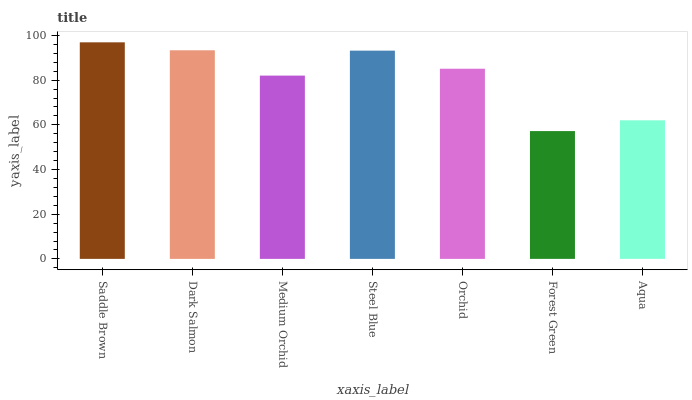Is Forest Green the minimum?
Answer yes or no. Yes. Is Saddle Brown the maximum?
Answer yes or no. Yes. Is Dark Salmon the minimum?
Answer yes or no. No. Is Dark Salmon the maximum?
Answer yes or no. No. Is Saddle Brown greater than Dark Salmon?
Answer yes or no. Yes. Is Dark Salmon less than Saddle Brown?
Answer yes or no. Yes. Is Dark Salmon greater than Saddle Brown?
Answer yes or no. No. Is Saddle Brown less than Dark Salmon?
Answer yes or no. No. Is Orchid the high median?
Answer yes or no. Yes. Is Orchid the low median?
Answer yes or no. Yes. Is Medium Orchid the high median?
Answer yes or no. No. Is Forest Green the low median?
Answer yes or no. No. 